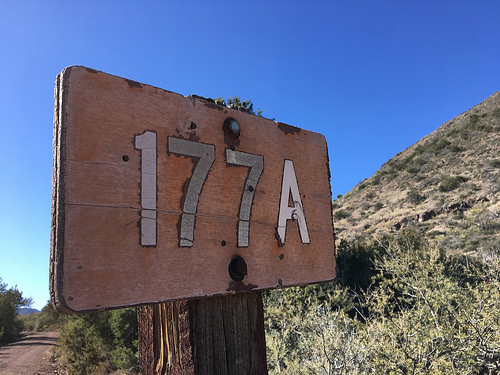<image>
Is there a number seven on the sign? Yes. Looking at the image, I can see the number seven is positioned on top of the sign, with the sign providing support. Is the sign on the mountain? No. The sign is not positioned on the mountain. They may be near each other, but the sign is not supported by or resting on top of the mountain. 